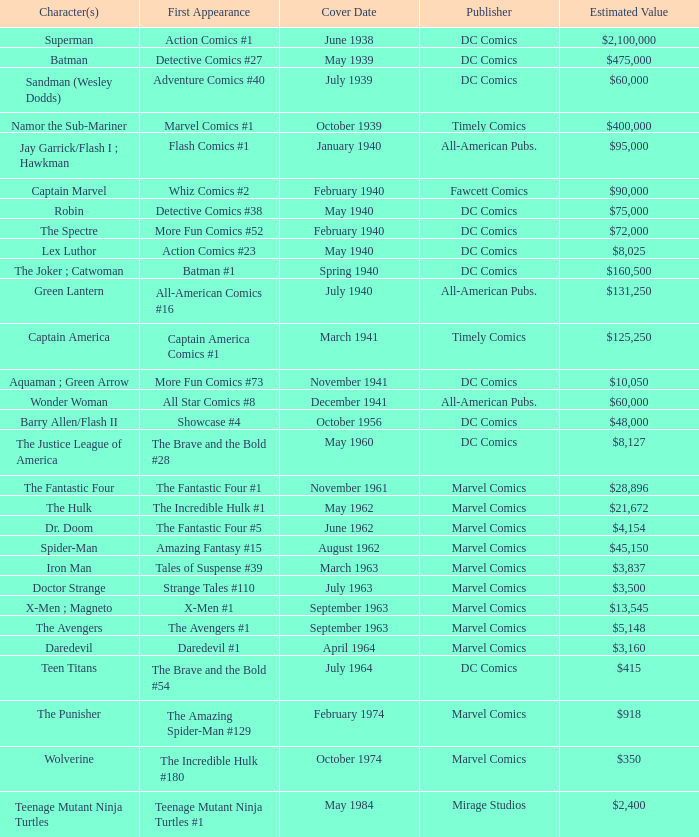Who releases wolverine? Marvel Comics. 